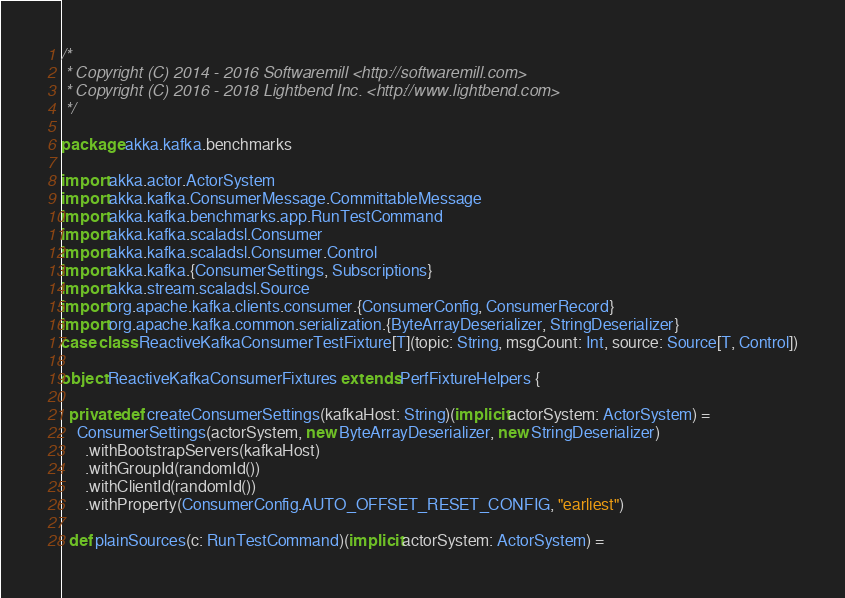Convert code to text. <code><loc_0><loc_0><loc_500><loc_500><_Scala_>/*
 * Copyright (C) 2014 - 2016 Softwaremill <http://softwaremill.com>
 * Copyright (C) 2016 - 2018 Lightbend Inc. <http://www.lightbend.com>
 */

package akka.kafka.benchmarks

import akka.actor.ActorSystem
import akka.kafka.ConsumerMessage.CommittableMessage
import akka.kafka.benchmarks.app.RunTestCommand
import akka.kafka.scaladsl.Consumer
import akka.kafka.scaladsl.Consumer.Control
import akka.kafka.{ConsumerSettings, Subscriptions}
import akka.stream.scaladsl.Source
import org.apache.kafka.clients.consumer.{ConsumerConfig, ConsumerRecord}
import org.apache.kafka.common.serialization.{ByteArrayDeserializer, StringDeserializer}
case class ReactiveKafkaConsumerTestFixture[T](topic: String, msgCount: Int, source: Source[T, Control])

object ReactiveKafkaConsumerFixtures extends PerfFixtureHelpers {

  private def createConsumerSettings(kafkaHost: String)(implicit actorSystem: ActorSystem) =
    ConsumerSettings(actorSystem, new ByteArrayDeserializer, new StringDeserializer)
      .withBootstrapServers(kafkaHost)
      .withGroupId(randomId())
      .withClientId(randomId())
      .withProperty(ConsumerConfig.AUTO_OFFSET_RESET_CONFIG, "earliest")

  def plainSources(c: RunTestCommand)(implicit actorSystem: ActorSystem) =</code> 